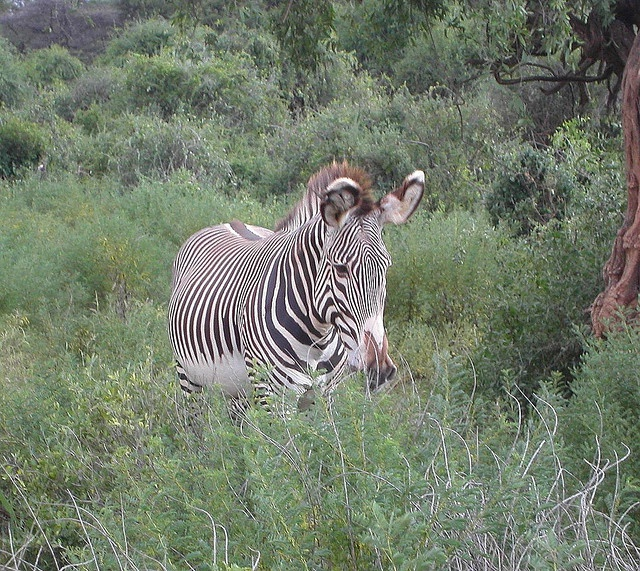Describe the objects in this image and their specific colors. I can see a zebra in gray, lightgray, darkgray, and black tones in this image. 